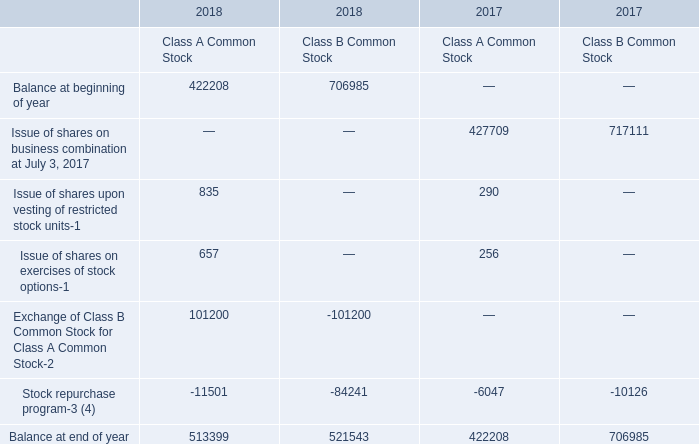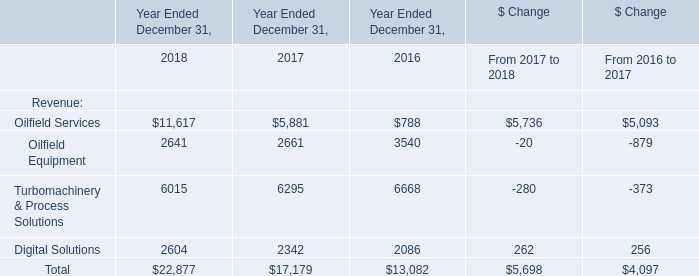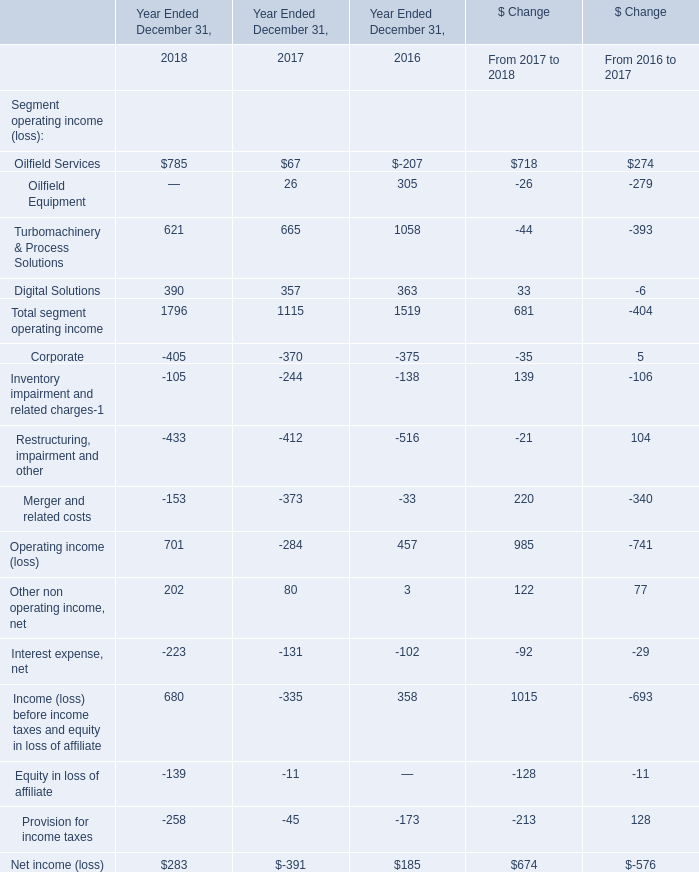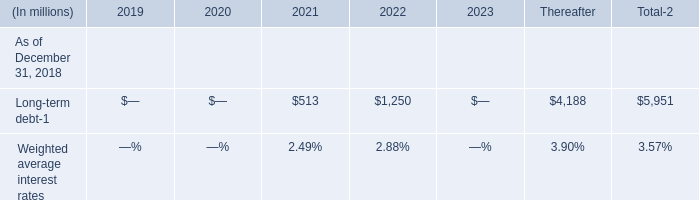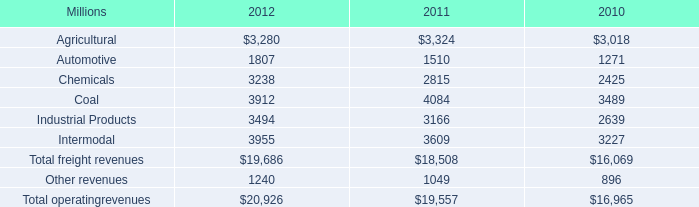What's the increasing rate of Total in 2018? (in %) 
Computations: ((22877 - 17179) / 17179)
Answer: 0.33168. 